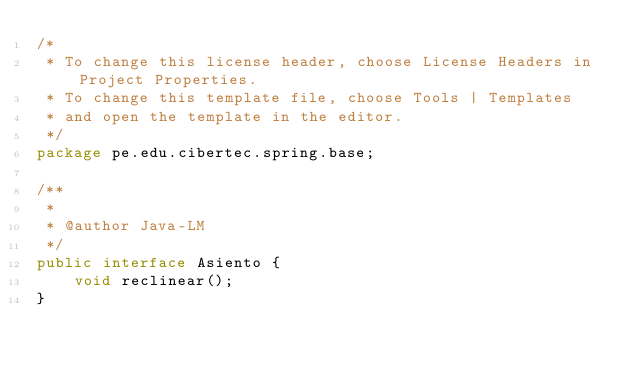Convert code to text. <code><loc_0><loc_0><loc_500><loc_500><_Java_>/*
 * To change this license header, choose License Headers in Project Properties.
 * To change this template file, choose Tools | Templates
 * and open the template in the editor.
 */
package pe.edu.cibertec.spring.base;

/**
 *
 * @author Java-LM
 */
public interface Asiento {
    void reclinear();
}
</code> 